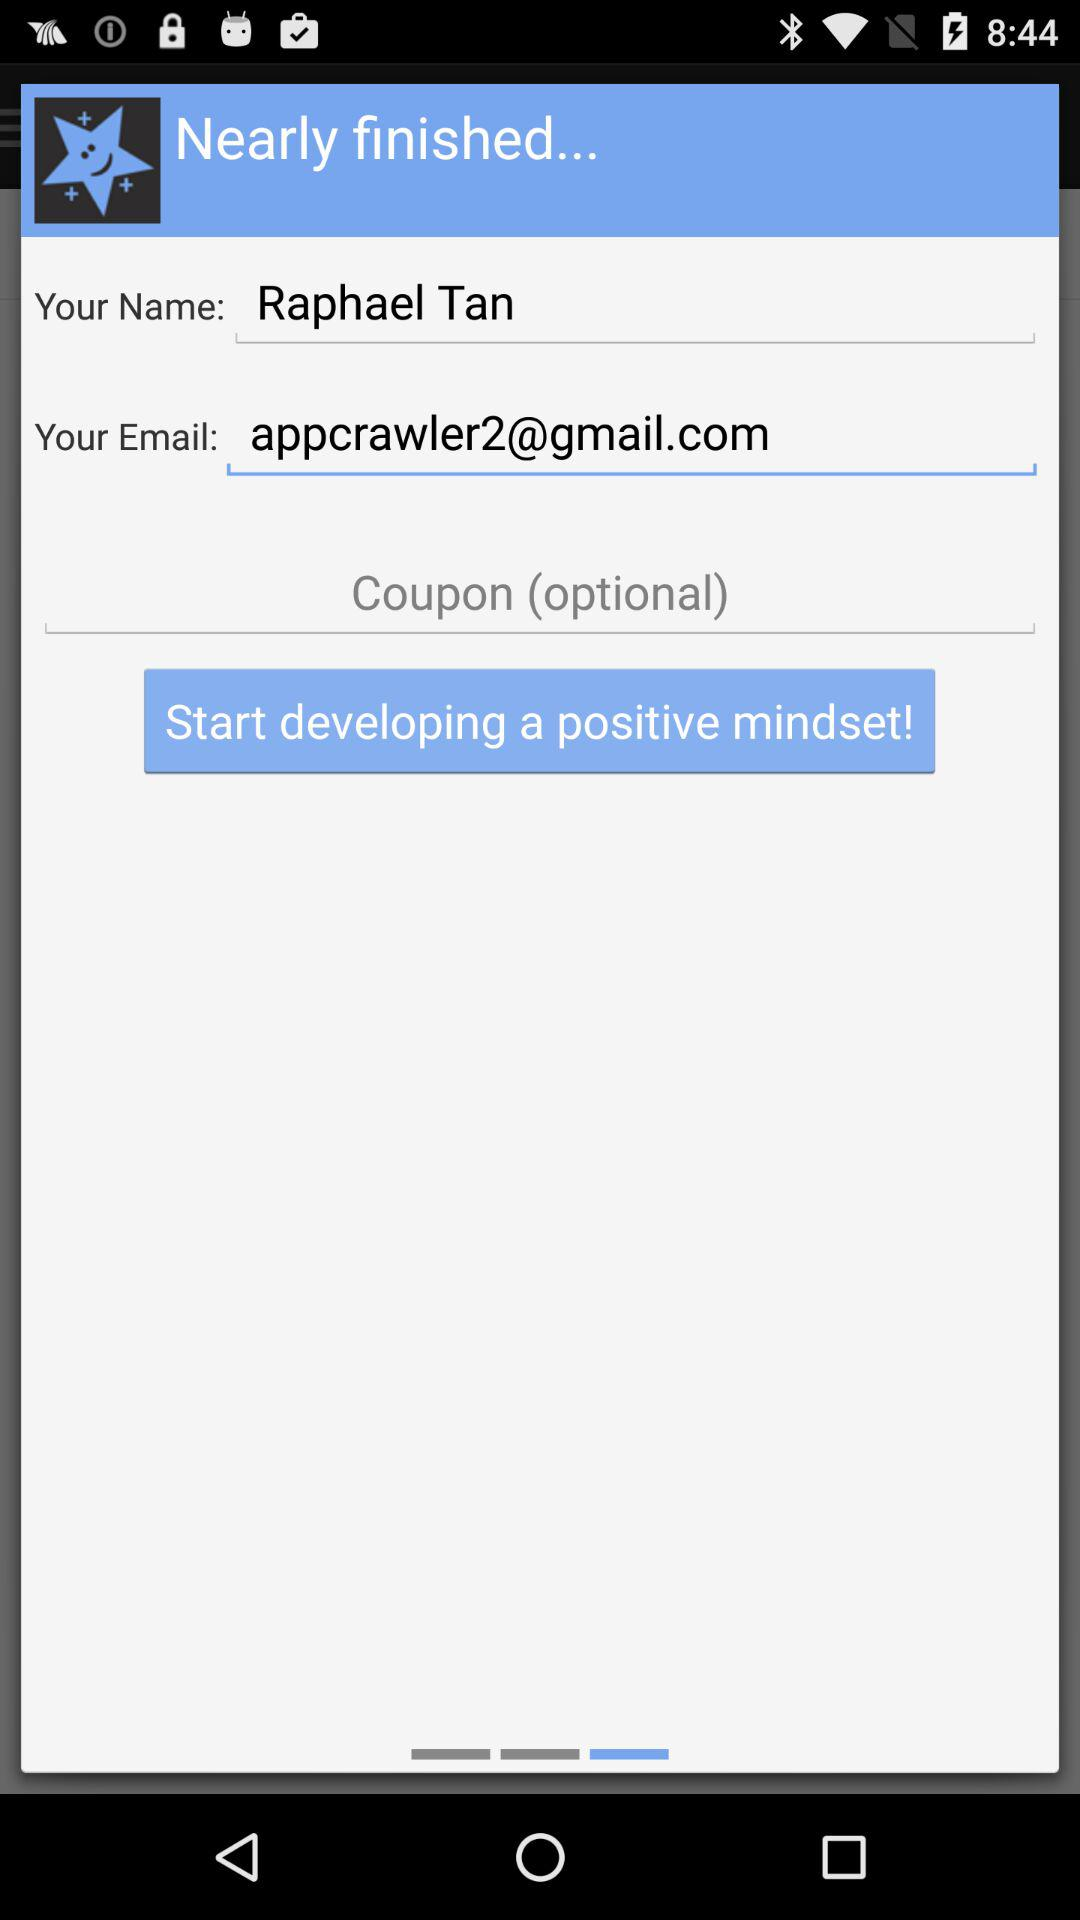What is the email address? The email address is appcrawler2@gmail.com. 